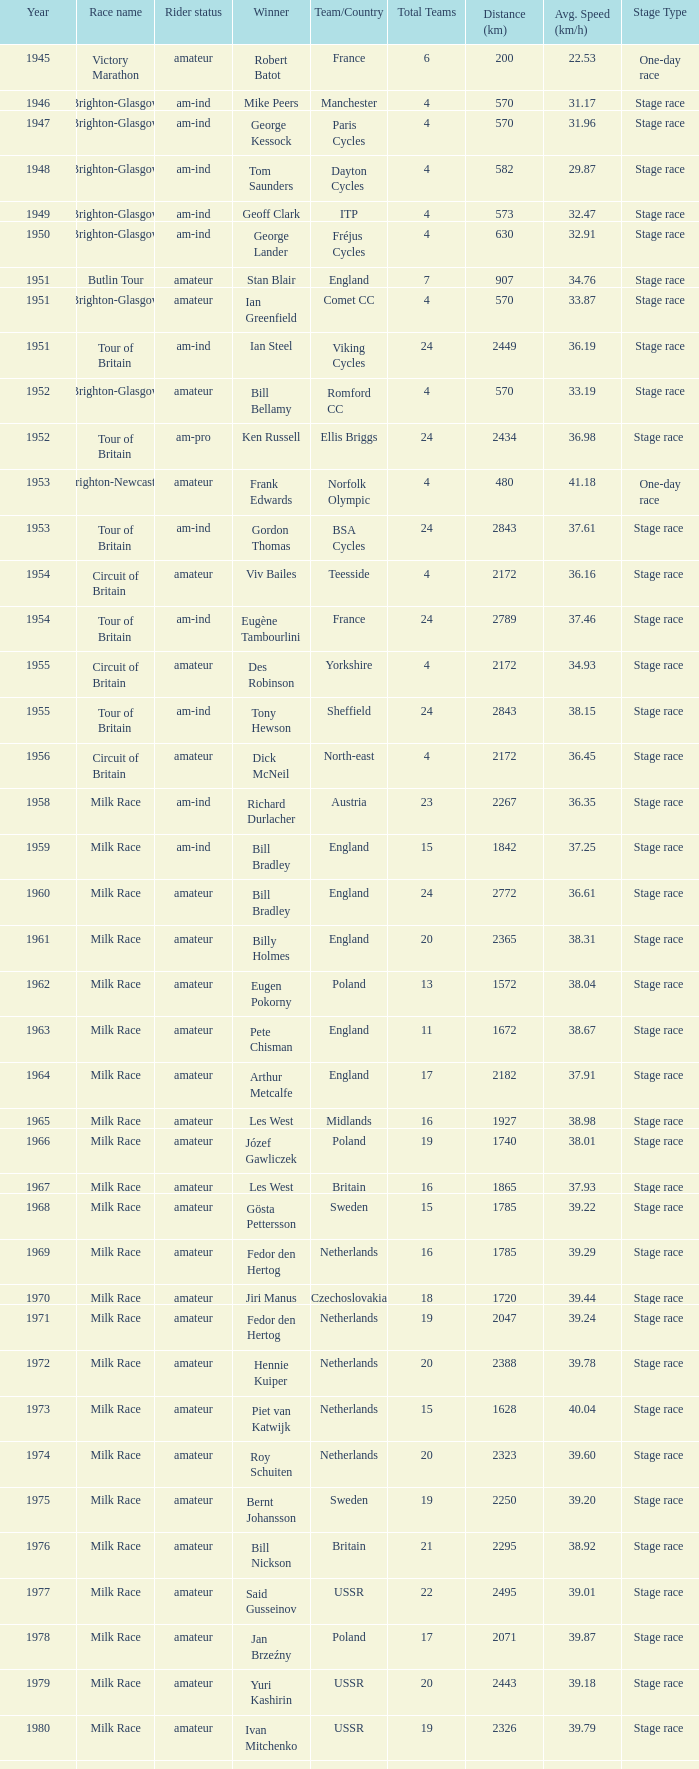What is the latest year when Phil Anderson won? 1993.0. 